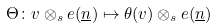<formula> <loc_0><loc_0><loc_500><loc_500>\Theta \colon v \otimes _ { s } e ( \underline { n } ) \mapsto \theta ( v ) \otimes _ { s } e ( \underline { n } )</formula> 